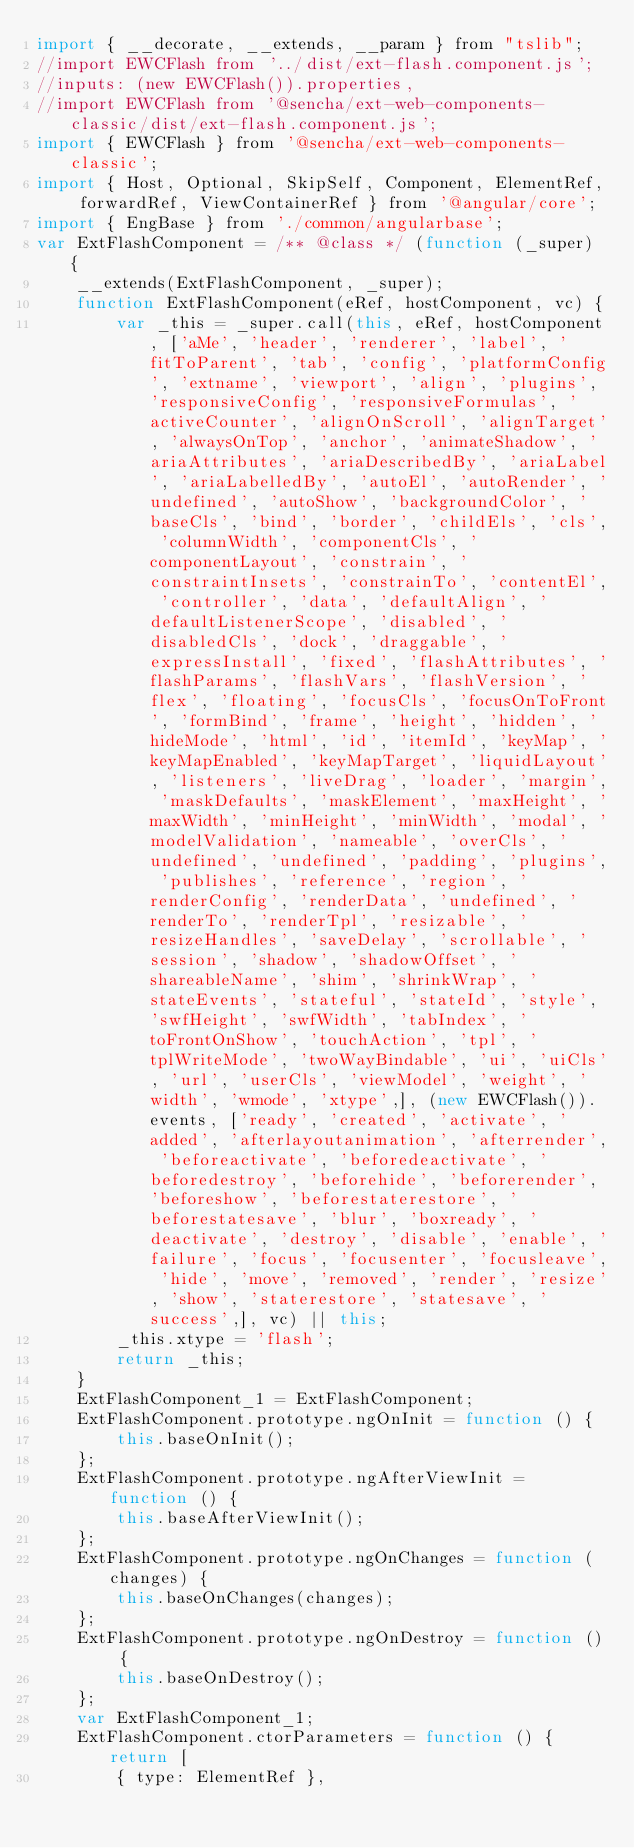<code> <loc_0><loc_0><loc_500><loc_500><_JavaScript_>import { __decorate, __extends, __param } from "tslib";
//import EWCFlash from '../dist/ext-flash.component.js';
//inputs: (new EWCFlash()).properties,
//import EWCFlash from '@sencha/ext-web-components-classic/dist/ext-flash.component.js';
import { EWCFlash } from '@sencha/ext-web-components-classic';
import { Host, Optional, SkipSelf, Component, ElementRef, forwardRef, ViewContainerRef } from '@angular/core';
import { EngBase } from './common/angularbase';
var ExtFlashComponent = /** @class */ (function (_super) {
    __extends(ExtFlashComponent, _super);
    function ExtFlashComponent(eRef, hostComponent, vc) {
        var _this = _super.call(this, eRef, hostComponent, ['aMe', 'header', 'renderer', 'label', 'fitToParent', 'tab', 'config', 'platformConfig', 'extname', 'viewport', 'align', 'plugins', 'responsiveConfig', 'responsiveFormulas', 'activeCounter', 'alignOnScroll', 'alignTarget', 'alwaysOnTop', 'anchor', 'animateShadow', 'ariaAttributes', 'ariaDescribedBy', 'ariaLabel', 'ariaLabelledBy', 'autoEl', 'autoRender', 'undefined', 'autoShow', 'backgroundColor', 'baseCls', 'bind', 'border', 'childEls', 'cls', 'columnWidth', 'componentCls', 'componentLayout', 'constrain', 'constraintInsets', 'constrainTo', 'contentEl', 'controller', 'data', 'defaultAlign', 'defaultListenerScope', 'disabled', 'disabledCls', 'dock', 'draggable', 'expressInstall', 'fixed', 'flashAttributes', 'flashParams', 'flashVars', 'flashVersion', 'flex', 'floating', 'focusCls', 'focusOnToFront', 'formBind', 'frame', 'height', 'hidden', 'hideMode', 'html', 'id', 'itemId', 'keyMap', 'keyMapEnabled', 'keyMapTarget', 'liquidLayout', 'listeners', 'liveDrag', 'loader', 'margin', 'maskDefaults', 'maskElement', 'maxHeight', 'maxWidth', 'minHeight', 'minWidth', 'modal', 'modelValidation', 'nameable', 'overCls', 'undefined', 'undefined', 'padding', 'plugins', 'publishes', 'reference', 'region', 'renderConfig', 'renderData', 'undefined', 'renderTo', 'renderTpl', 'resizable', 'resizeHandles', 'saveDelay', 'scrollable', 'session', 'shadow', 'shadowOffset', 'shareableName', 'shim', 'shrinkWrap', 'stateEvents', 'stateful', 'stateId', 'style', 'swfHeight', 'swfWidth', 'tabIndex', 'toFrontOnShow', 'touchAction', 'tpl', 'tplWriteMode', 'twoWayBindable', 'ui', 'uiCls', 'url', 'userCls', 'viewModel', 'weight', 'width', 'wmode', 'xtype',], (new EWCFlash()).events, ['ready', 'created', 'activate', 'added', 'afterlayoutanimation', 'afterrender', 'beforeactivate', 'beforedeactivate', 'beforedestroy', 'beforehide', 'beforerender', 'beforeshow', 'beforestaterestore', 'beforestatesave', 'blur', 'boxready', 'deactivate', 'destroy', 'disable', 'enable', 'failure', 'focus', 'focusenter', 'focusleave', 'hide', 'move', 'removed', 'render', 'resize', 'show', 'staterestore', 'statesave', 'success',], vc) || this;
        _this.xtype = 'flash';
        return _this;
    }
    ExtFlashComponent_1 = ExtFlashComponent;
    ExtFlashComponent.prototype.ngOnInit = function () {
        this.baseOnInit();
    };
    ExtFlashComponent.prototype.ngAfterViewInit = function () {
        this.baseAfterViewInit();
    };
    ExtFlashComponent.prototype.ngOnChanges = function (changes) {
        this.baseOnChanges(changes);
    };
    ExtFlashComponent.prototype.ngOnDestroy = function () {
        this.baseOnDestroy();
    };
    var ExtFlashComponent_1;
    ExtFlashComponent.ctorParameters = function () { return [
        { type: ElementRef },</code> 